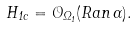Convert formula to latex. <formula><loc_0><loc_0><loc_500><loc_500>H _ { 1 c } = { \mathcal { O } } _ { \Omega _ { 1 } } ( R a n \, \Gamma ) .</formula> 